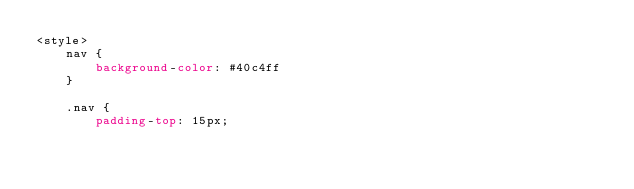Convert code to text. <code><loc_0><loc_0><loc_500><loc_500><_CSS_><style>
    nav {
        background-color: #40c4ff
    }

    .nav {
        padding-top: 15px;</code> 